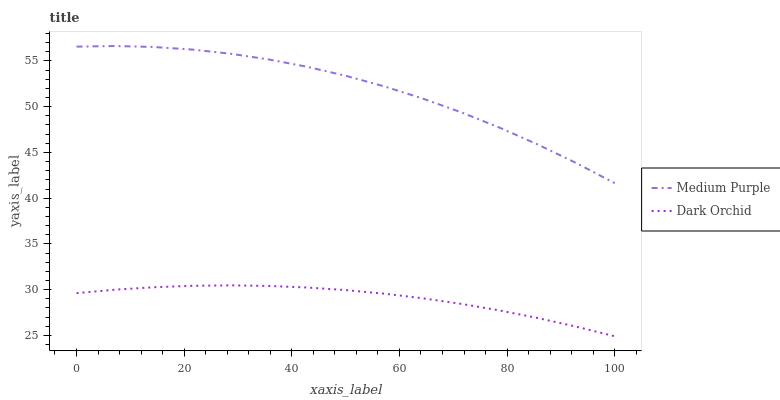Does Dark Orchid have the maximum area under the curve?
Answer yes or no. No. Is Dark Orchid the roughest?
Answer yes or no. No. Does Dark Orchid have the highest value?
Answer yes or no. No. Is Dark Orchid less than Medium Purple?
Answer yes or no. Yes. Is Medium Purple greater than Dark Orchid?
Answer yes or no. Yes. Does Dark Orchid intersect Medium Purple?
Answer yes or no. No. 